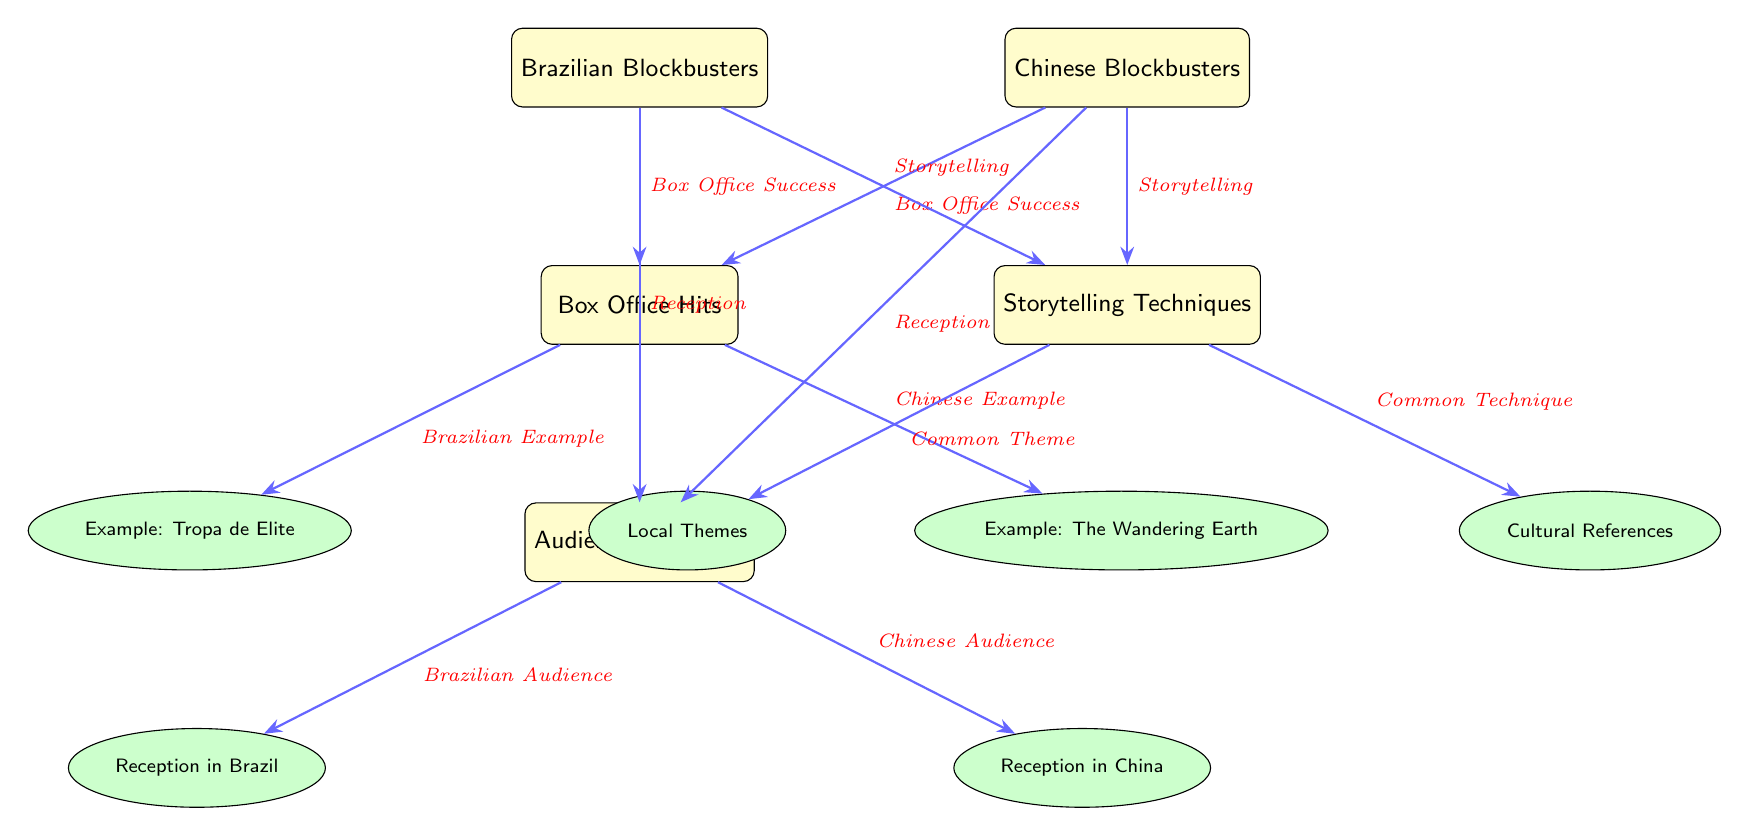What's the first node linked to "Box Office Hits" from Brazilian Blockbusters? The first node linked to "Box Office Hits" from Brazilian Blockbusters is "Box Office Success," which indicates that Brazilian blockbusters have a relationship with box office performance.
Answer: Box Office Success How many examples are provided in the diagram? There are two examples provided in the diagram: "Tropa de Elite" under Brazilian blockbusters and "The Wandering Earth" under Chinese blockbusters. The total is counted by examining the nodes with the example style.
Answer: 2 Which node represents a specific example of Chinese blockbusters? The node representing a specific example of Chinese blockbusters is "The Wandering Earth," as indicated in the diagram under the category of "Box Office Hits."
Answer: The Wandering Earth What type of storytelling technique is represented in the diagram? The diagram highlights "Common Theme" and "Common Technique" as storytelling techniques, showing how both Brazilian and Chinese blockbusters share similar approaches.
Answer: Common Theme and Common Technique What does the arrow from "Box Office Hits" to "Audience Reception" represent? The arrow from "Box Office Hits" to "Audience Reception" signifies the impact that box office performance has on how audiences perceive and receive films in both Brazil and China.
Answer: Impact of Box Office Performance Which example is linked to "Reception in Brazil"? The example linked to "Reception in Brazil" is specifically located under the "Audience Reception" node and provided as a response to Brazilian audiences' perception of local blockbusters.
Answer: Reception in Brazil 